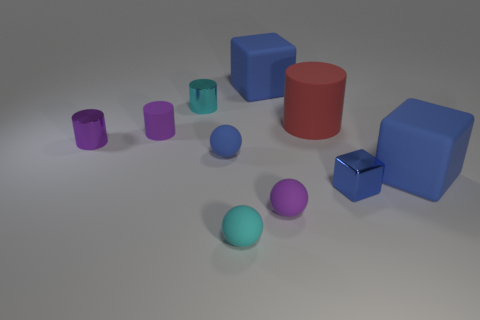Subtract all tiny blue matte balls. How many balls are left? 2 Subtract all blue balls. How many balls are left? 2 Subtract 1 spheres. How many spheres are left? 2 Subtract all red cylinders. How many yellow blocks are left? 0 Subtract all red rubber cylinders. Subtract all small purple metal objects. How many objects are left? 8 Add 3 big rubber objects. How many big rubber objects are left? 6 Add 4 large brown cubes. How many large brown cubes exist? 4 Subtract 0 green cubes. How many objects are left? 10 Subtract all balls. How many objects are left? 7 Subtract all brown blocks. Subtract all brown cylinders. How many blocks are left? 3 